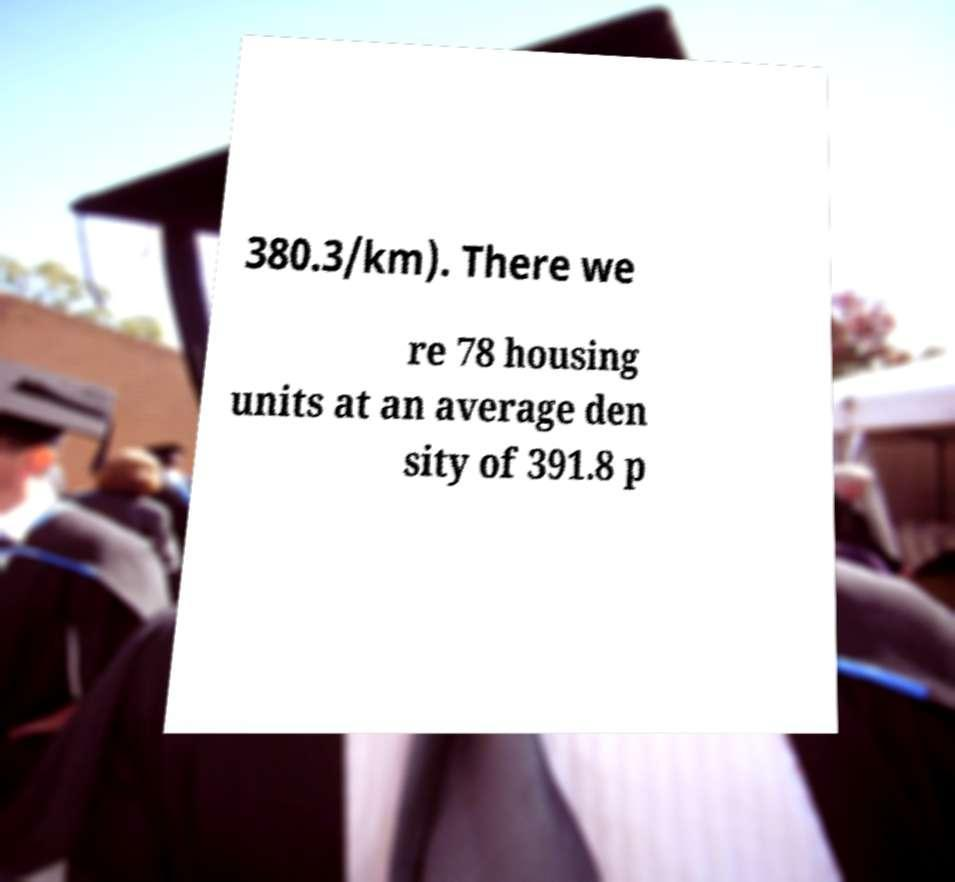Please read and relay the text visible in this image. What does it say? 380.3/km). There we re 78 housing units at an average den sity of 391.8 p 